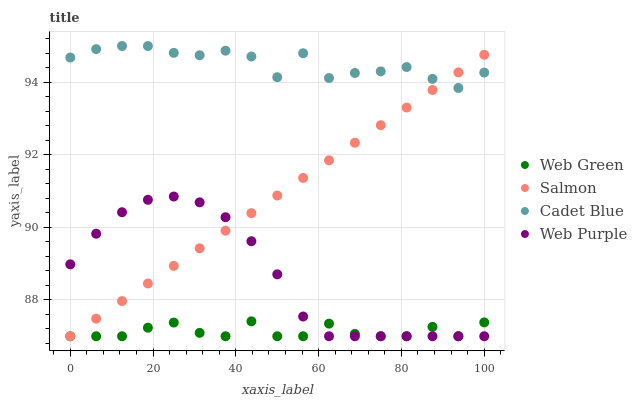Does Web Green have the minimum area under the curve?
Answer yes or no. Yes. Does Cadet Blue have the maximum area under the curve?
Answer yes or no. Yes. Does Salmon have the minimum area under the curve?
Answer yes or no. No. Does Salmon have the maximum area under the curve?
Answer yes or no. No. Is Salmon the smoothest?
Answer yes or no. Yes. Is Cadet Blue the roughest?
Answer yes or no. Yes. Is Cadet Blue the smoothest?
Answer yes or no. No. Is Salmon the roughest?
Answer yes or no. No. Does Web Purple have the lowest value?
Answer yes or no. Yes. Does Cadet Blue have the lowest value?
Answer yes or no. No. Does Cadet Blue have the highest value?
Answer yes or no. Yes. Does Salmon have the highest value?
Answer yes or no. No. Is Web Green less than Cadet Blue?
Answer yes or no. Yes. Is Cadet Blue greater than Web Purple?
Answer yes or no. Yes. Does Web Green intersect Salmon?
Answer yes or no. Yes. Is Web Green less than Salmon?
Answer yes or no. No. Is Web Green greater than Salmon?
Answer yes or no. No. Does Web Green intersect Cadet Blue?
Answer yes or no. No. 